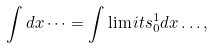<formula> <loc_0><loc_0><loc_500><loc_500>\int d x \dots = \int \lim i t s _ { 0 } ^ { 1 } d x \dots ,</formula> 